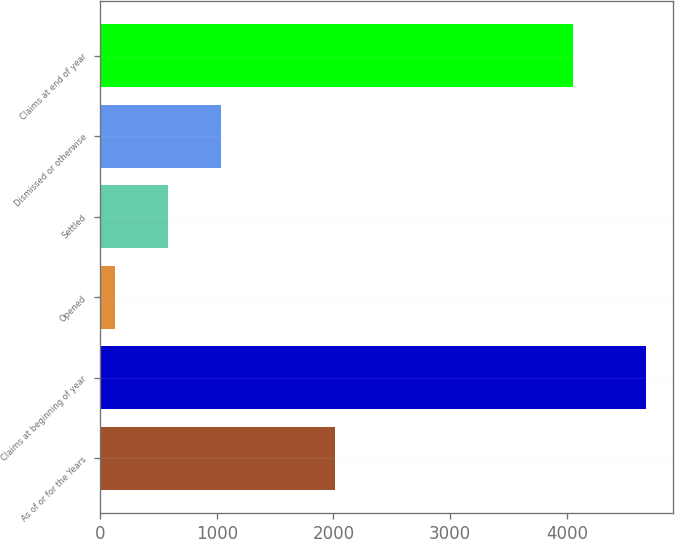Convert chart to OTSL. <chart><loc_0><loc_0><loc_500><loc_500><bar_chart><fcel>As of or for the Years<fcel>Claims at beginning of year<fcel>Opened<fcel>Settled<fcel>Dismissed or otherwise<fcel>Claims at end of year<nl><fcel>2014<fcel>4680<fcel>130<fcel>585<fcel>1040<fcel>4049<nl></chart> 